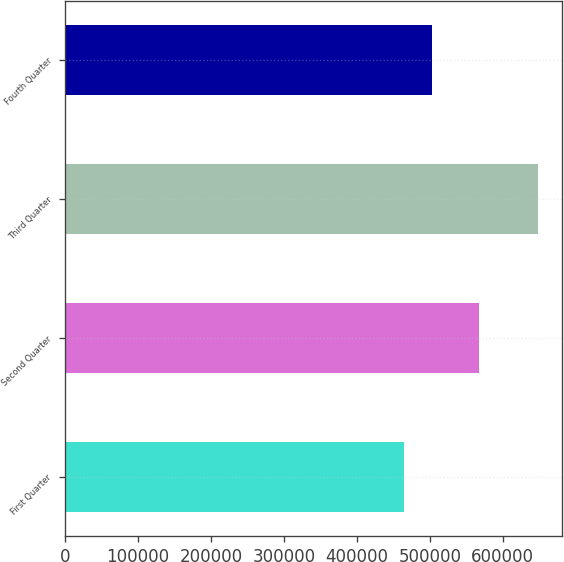Convert chart to OTSL. <chart><loc_0><loc_0><loc_500><loc_500><bar_chart><fcel>First Quarter<fcel>Second Quarter<fcel>Third Quarter<fcel>Fourth Quarter<nl><fcel>463904<fcel>567563<fcel>648849<fcel>503563<nl></chart> 